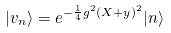<formula> <loc_0><loc_0><loc_500><loc_500>| v _ { n } \rangle = e ^ { - { \frac { 1 } { 4 } } g ^ { 2 } ( X + y ) ^ { 2 } } | n \rangle</formula> 